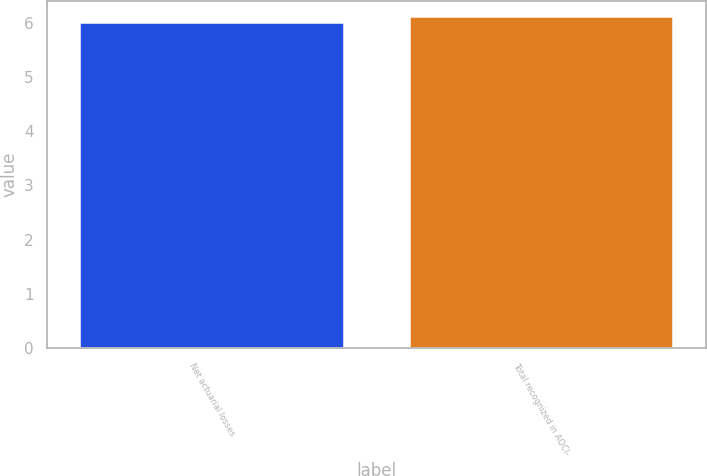<chart> <loc_0><loc_0><loc_500><loc_500><bar_chart><fcel>Net actuarial losses<fcel>Total recognized in AOCI-<nl><fcel>6<fcel>6.1<nl></chart> 